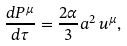Convert formula to latex. <formula><loc_0><loc_0><loc_500><loc_500>\frac { d P ^ { \mu } } { d \tau } = \frac { 2 \alpha } { 3 } a ^ { 2 } \, u ^ { \mu } ,</formula> 